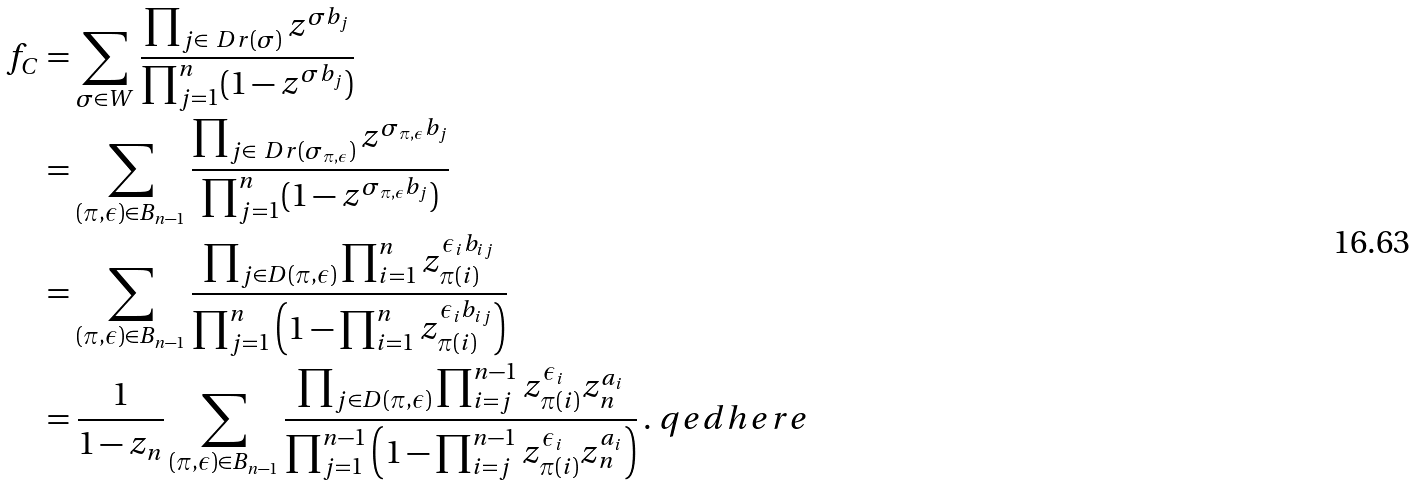Convert formula to latex. <formula><loc_0><loc_0><loc_500><loc_500>f _ { C } & = \sum _ { \sigma \in W } \frac { \prod _ { j \in \ D r ( \sigma ) } z ^ { \sigma b _ { j } } } { \prod _ { j = 1 } ^ { n } ( 1 - z ^ { \sigma b _ { j } } ) } \\ & = \sum _ { ( \pi , \epsilon ) \in B _ { n - 1 } } \frac { \prod _ { j \in \ D r ( \sigma _ { \pi , \epsilon } ) } z ^ { \sigma _ { \pi , \epsilon } b _ { j } } } { \prod _ { j = 1 } ^ { n } ( 1 - z ^ { \sigma _ { \pi , \epsilon } b _ { j } } ) } \\ & = \sum _ { ( \pi , \epsilon ) \in B _ { n - 1 } } \frac { \prod _ { j \in D ( \pi , \epsilon ) } \prod _ { i = 1 } ^ { n } z _ { \pi ( i ) } ^ { \epsilon _ { i } b _ { i j } } } { \prod _ { j = 1 } ^ { n } \left ( 1 - \prod _ { i = 1 } ^ { n } z _ { \pi ( i ) } ^ { \epsilon _ { i } b _ { i j } } \right ) } \\ & = \frac { 1 } { 1 - z _ { n } } \sum _ { ( \pi , \epsilon ) \in B _ { n - 1 } } \frac { \prod _ { j \in D ( \pi , \epsilon ) } \prod _ { i = j } ^ { n - 1 } z _ { \pi ( i ) } ^ { \epsilon _ { i } } z _ { n } ^ { a _ { i } } } { \prod _ { j = 1 } ^ { n - 1 } \left ( 1 - \prod _ { i = j } ^ { n - 1 } z _ { \pi ( i ) } ^ { \epsilon _ { i } } z _ { n } ^ { a _ { i } } \right ) } \, . \ q e d h e r e</formula> 